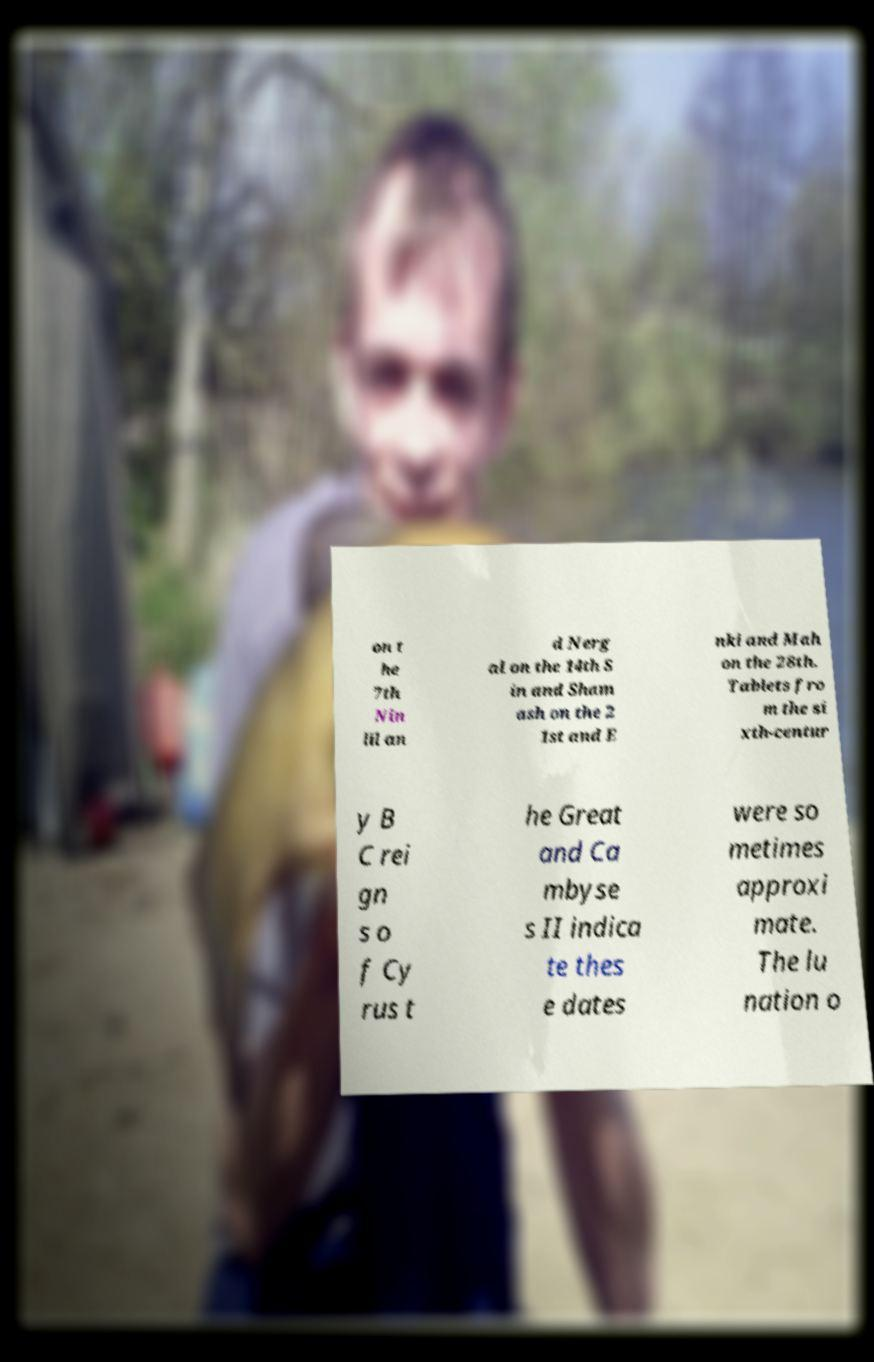Can you read and provide the text displayed in the image?This photo seems to have some interesting text. Can you extract and type it out for me? on t he 7th Nin lil an d Nerg al on the 14th S in and Sham ash on the 2 1st and E nki and Mah on the 28th. Tablets fro m the si xth-centur y B C rei gn s o f Cy rus t he Great and Ca mbyse s II indica te thes e dates were so metimes approxi mate. The lu nation o 